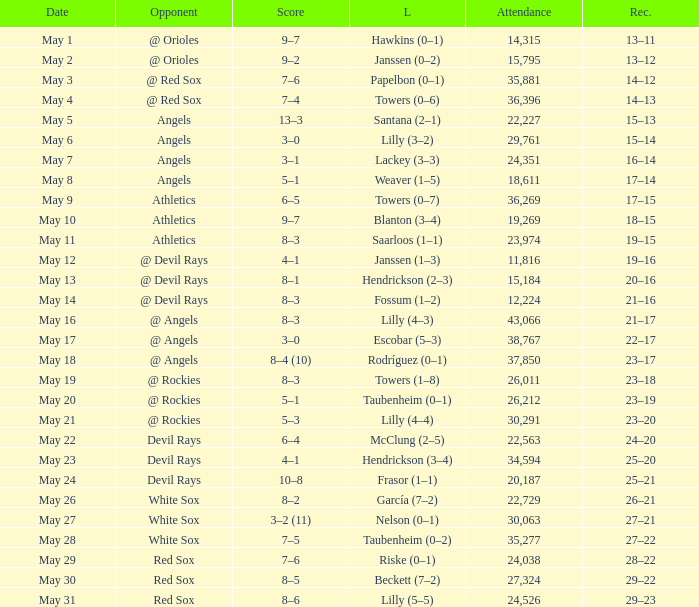What was the average attendance for games with a loss of papelbon (0–1)? 35881.0. 